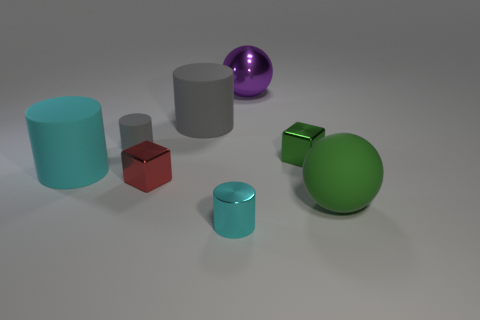How would you describe the composition of the objects in this image? The objects are arranged in a balanced, yet asymmetric composition. Different geometric shapes like cylinders, cubes, and spheres are positioned with consideration to create a harmonious visual. The spacing between the objects is even, which allows each object to stand out without clutter. 